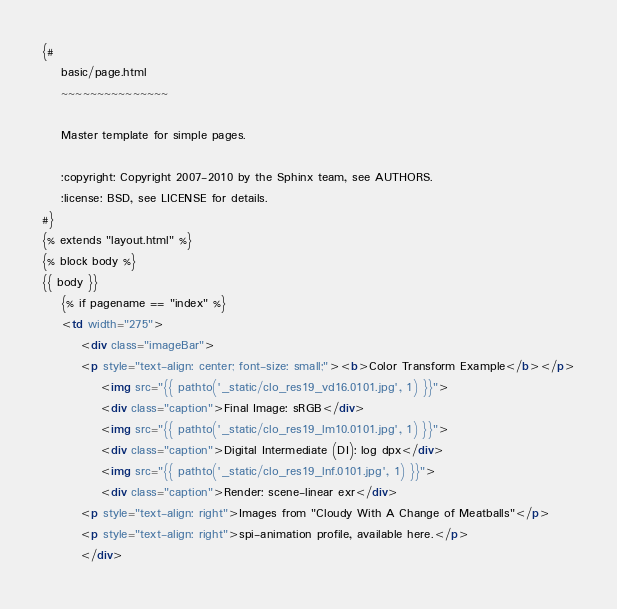<code> <loc_0><loc_0><loc_500><loc_500><_HTML_>{#
    basic/page.html
    ~~~~~~~~~~~~~~~

    Master template for simple pages.

    :copyright: Copyright 2007-2010 by the Sphinx team, see AUTHORS.
    :license: BSD, see LICENSE for details.
#}
{% extends "layout.html" %}
{% block body %}
{{ body }}
    {% if pagename == "index" %}
    <td width="275">
        <div class="imageBar">
        <p style="text-align: center; font-size: small;"><b>Color Transform Example</b></p>
            <img src="{{ pathto('_static/clo_res19_vd16.0101.jpg', 1) }}">
            <div class="caption">Final Image: sRGB</div>
            <img src="{{ pathto('_static/clo_res19_lm10.0101.jpg', 1) }}">  
            <div class="caption">Digital Intermediate (DI): log dpx</div>
            <img src="{{ pathto('_static/clo_res19_lnf.0101.jpg', 1) }}">
            <div class="caption">Render: scene-linear exr</div>
        <p style="text-align: right">Images from "Cloudy With A Change of Meatballs"</p>
        <p style="text-align: right">spi-animation profile, available here.</p>
        </div></code> 